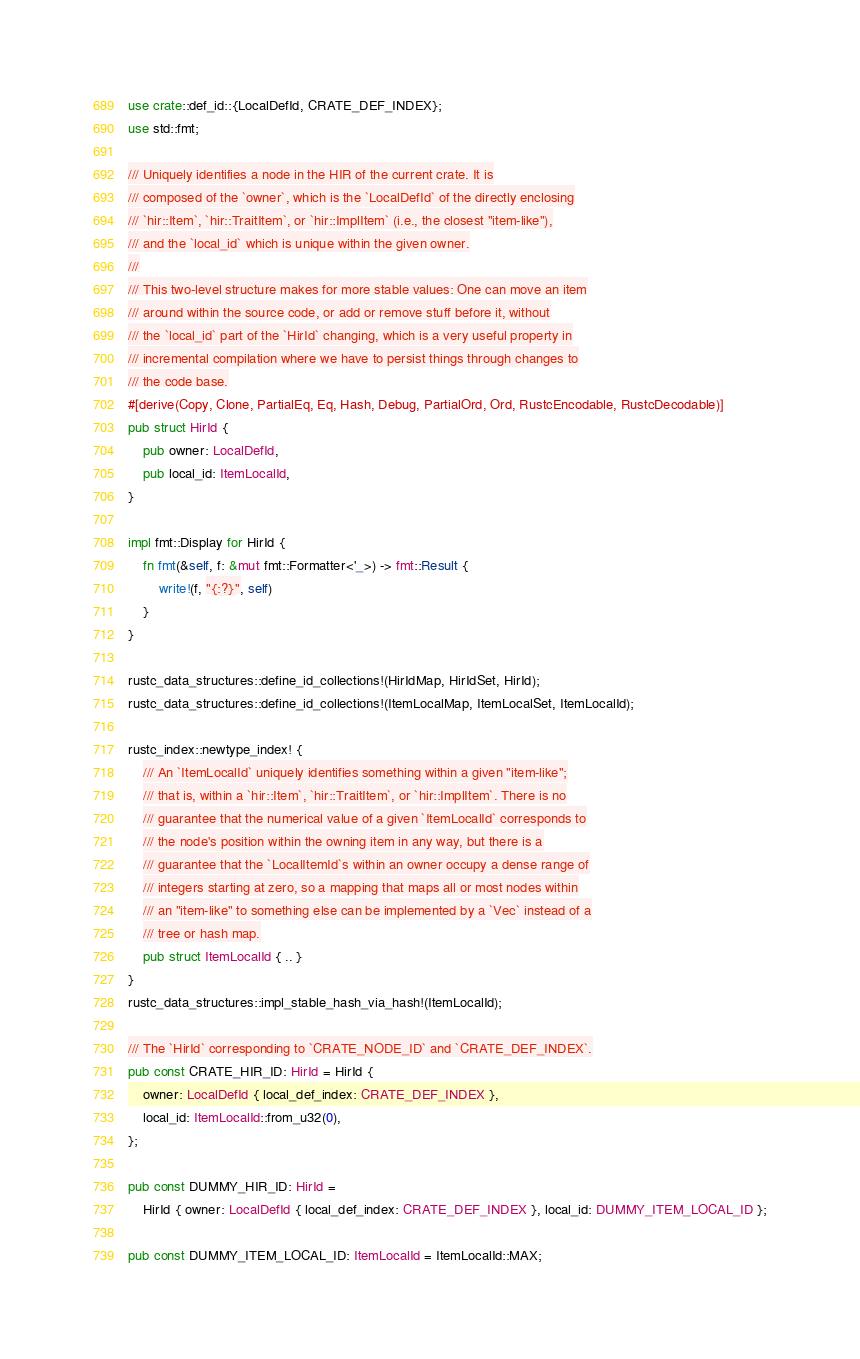Convert code to text. <code><loc_0><loc_0><loc_500><loc_500><_Rust_>use crate::def_id::{LocalDefId, CRATE_DEF_INDEX};
use std::fmt;

/// Uniquely identifies a node in the HIR of the current crate. It is
/// composed of the `owner`, which is the `LocalDefId` of the directly enclosing
/// `hir::Item`, `hir::TraitItem`, or `hir::ImplItem` (i.e., the closest "item-like"),
/// and the `local_id` which is unique within the given owner.
///
/// This two-level structure makes for more stable values: One can move an item
/// around within the source code, or add or remove stuff before it, without
/// the `local_id` part of the `HirId` changing, which is a very useful property in
/// incremental compilation where we have to persist things through changes to
/// the code base.
#[derive(Copy, Clone, PartialEq, Eq, Hash, Debug, PartialOrd, Ord, RustcEncodable, RustcDecodable)]
pub struct HirId {
    pub owner: LocalDefId,
    pub local_id: ItemLocalId,
}

impl fmt::Display for HirId {
    fn fmt(&self, f: &mut fmt::Formatter<'_>) -> fmt::Result {
        write!(f, "{:?}", self)
    }
}

rustc_data_structures::define_id_collections!(HirIdMap, HirIdSet, HirId);
rustc_data_structures::define_id_collections!(ItemLocalMap, ItemLocalSet, ItemLocalId);

rustc_index::newtype_index! {
    /// An `ItemLocalId` uniquely identifies something within a given "item-like";
    /// that is, within a `hir::Item`, `hir::TraitItem`, or `hir::ImplItem`. There is no
    /// guarantee that the numerical value of a given `ItemLocalId` corresponds to
    /// the node's position within the owning item in any way, but there is a
    /// guarantee that the `LocalItemId`s within an owner occupy a dense range of
    /// integers starting at zero, so a mapping that maps all or most nodes within
    /// an "item-like" to something else can be implemented by a `Vec` instead of a
    /// tree or hash map.
    pub struct ItemLocalId { .. }
}
rustc_data_structures::impl_stable_hash_via_hash!(ItemLocalId);

/// The `HirId` corresponding to `CRATE_NODE_ID` and `CRATE_DEF_INDEX`.
pub const CRATE_HIR_ID: HirId = HirId {
    owner: LocalDefId { local_def_index: CRATE_DEF_INDEX },
    local_id: ItemLocalId::from_u32(0),
};

pub const DUMMY_HIR_ID: HirId =
    HirId { owner: LocalDefId { local_def_index: CRATE_DEF_INDEX }, local_id: DUMMY_ITEM_LOCAL_ID };

pub const DUMMY_ITEM_LOCAL_ID: ItemLocalId = ItemLocalId::MAX;
</code> 